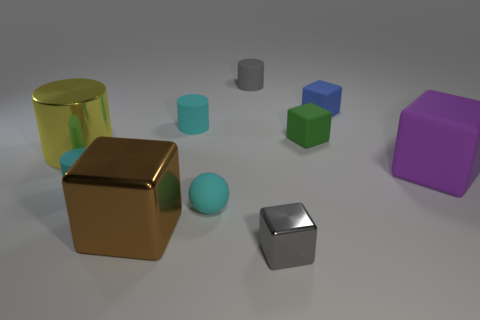Subtract all green cubes. How many cubes are left? 4 Subtract all green rubber blocks. How many blocks are left? 4 Subtract all red blocks. Subtract all blue spheres. How many blocks are left? 5 Subtract all balls. How many objects are left? 9 Subtract 0 red balls. How many objects are left? 10 Subtract all purple shiny things. Subtract all small cyan matte things. How many objects are left? 7 Add 5 big brown metallic things. How many big brown metallic things are left? 6 Add 8 tiny blue things. How many tiny blue things exist? 9 